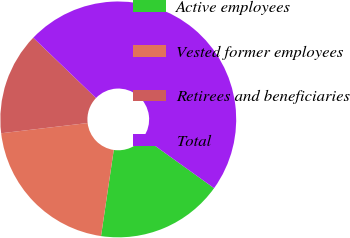Convert chart. <chart><loc_0><loc_0><loc_500><loc_500><pie_chart><fcel>Active employees<fcel>Vested former employees<fcel>Retirees and beneficiaries<fcel>Total<nl><fcel>17.43%<fcel>20.79%<fcel>14.06%<fcel>47.72%<nl></chart> 